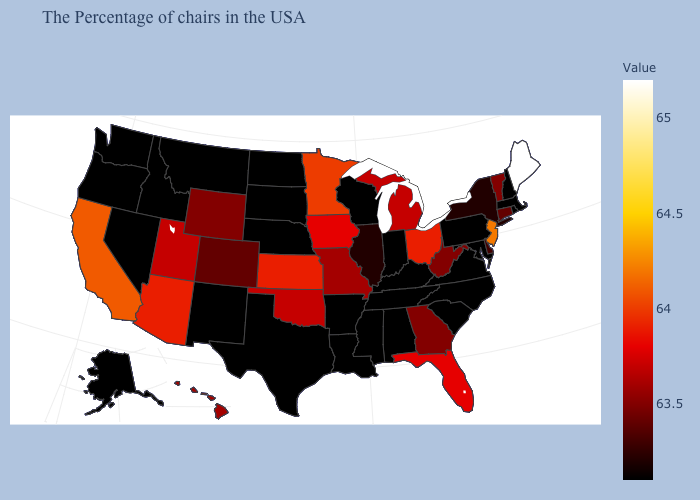Which states hav the highest value in the West?
Keep it brief. California. Which states have the lowest value in the USA?
Answer briefly. Massachusetts, Rhode Island, New Hampshire, Maryland, Pennsylvania, Virginia, North Carolina, South Carolina, Kentucky, Indiana, Alabama, Tennessee, Wisconsin, Mississippi, Louisiana, Arkansas, Nebraska, Texas, South Dakota, North Dakota, New Mexico, Montana, Idaho, Nevada, Washington, Oregon, Alaska. Does Maine have the highest value in the USA?
Write a very short answer. Yes. Does the map have missing data?
Answer briefly. No. Does Tennessee have the highest value in the South?
Be succinct. No. 